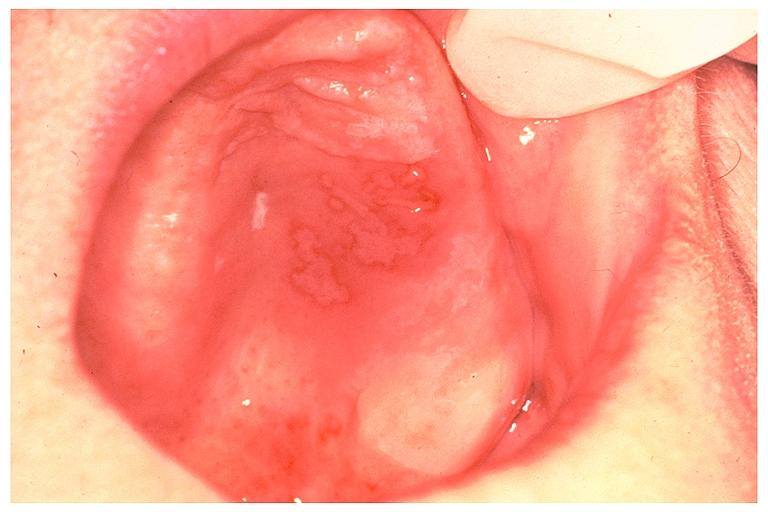s normal ovary present?
Answer the question using a single word or phrase. No 